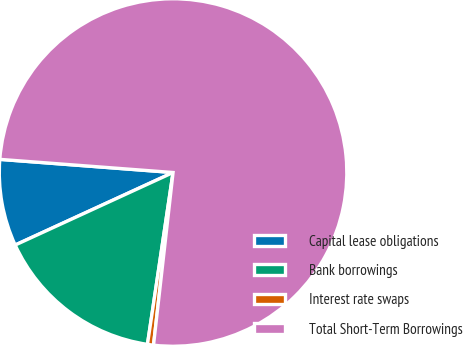Convert chart. <chart><loc_0><loc_0><loc_500><loc_500><pie_chart><fcel>Capital lease obligations<fcel>Bank borrowings<fcel>Interest rate swaps<fcel>Total Short-Term Borrowings<nl><fcel>8.06%<fcel>15.79%<fcel>0.56%<fcel>75.58%<nl></chart> 